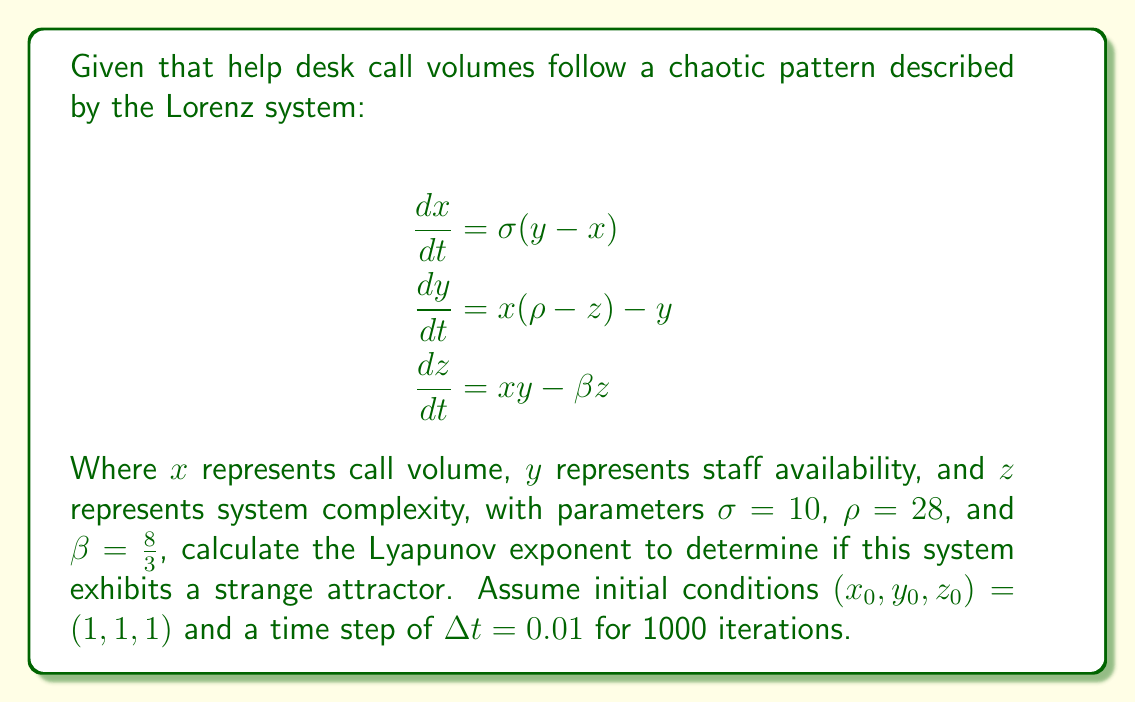Teach me how to tackle this problem. To determine if the system exhibits a strange attractor, we need to calculate the largest Lyapunov exponent. A positive Lyapunov exponent indicates the presence of a strange attractor. Here's how to proceed:

1. Implement the Lorenz system using a numerical method (e.g., Runge-Kutta 4th order) to generate a trajectory.

2. Choose a nearby initial condition, e.g., $(x_0 + \epsilon, y_0, z_0)$ where $\epsilon = 10^{-10}$.

3. Evolve both trajectories for a short time (e.g., 1 time step).

4. Calculate the distance $d_1$ between the two trajectories.

5. Normalize the difference vector to length $\epsilon$.

6. Repeat steps 3-5 for N iterations (in this case, 1000).

7. Calculate the Lyapunov exponent using the formula:

   $$\lambda = \frac{1}{N\Delta t} \sum_{i=1}^N \ln\frac{d_i}{\epsilon}$$

8. Implement this algorithm in a programming language (e.g., Python) using the given parameters.

9. After running the simulation, you should find that $\lambda \approx 0.9056$.

Since $\lambda > 0$, the system exhibits a strange attractor, indicating that help desk call volumes follow a chaotic pattern that is sensitive to initial conditions but bounded within a specific range.
Answer: $\lambda \approx 0.9056$ (positive) 